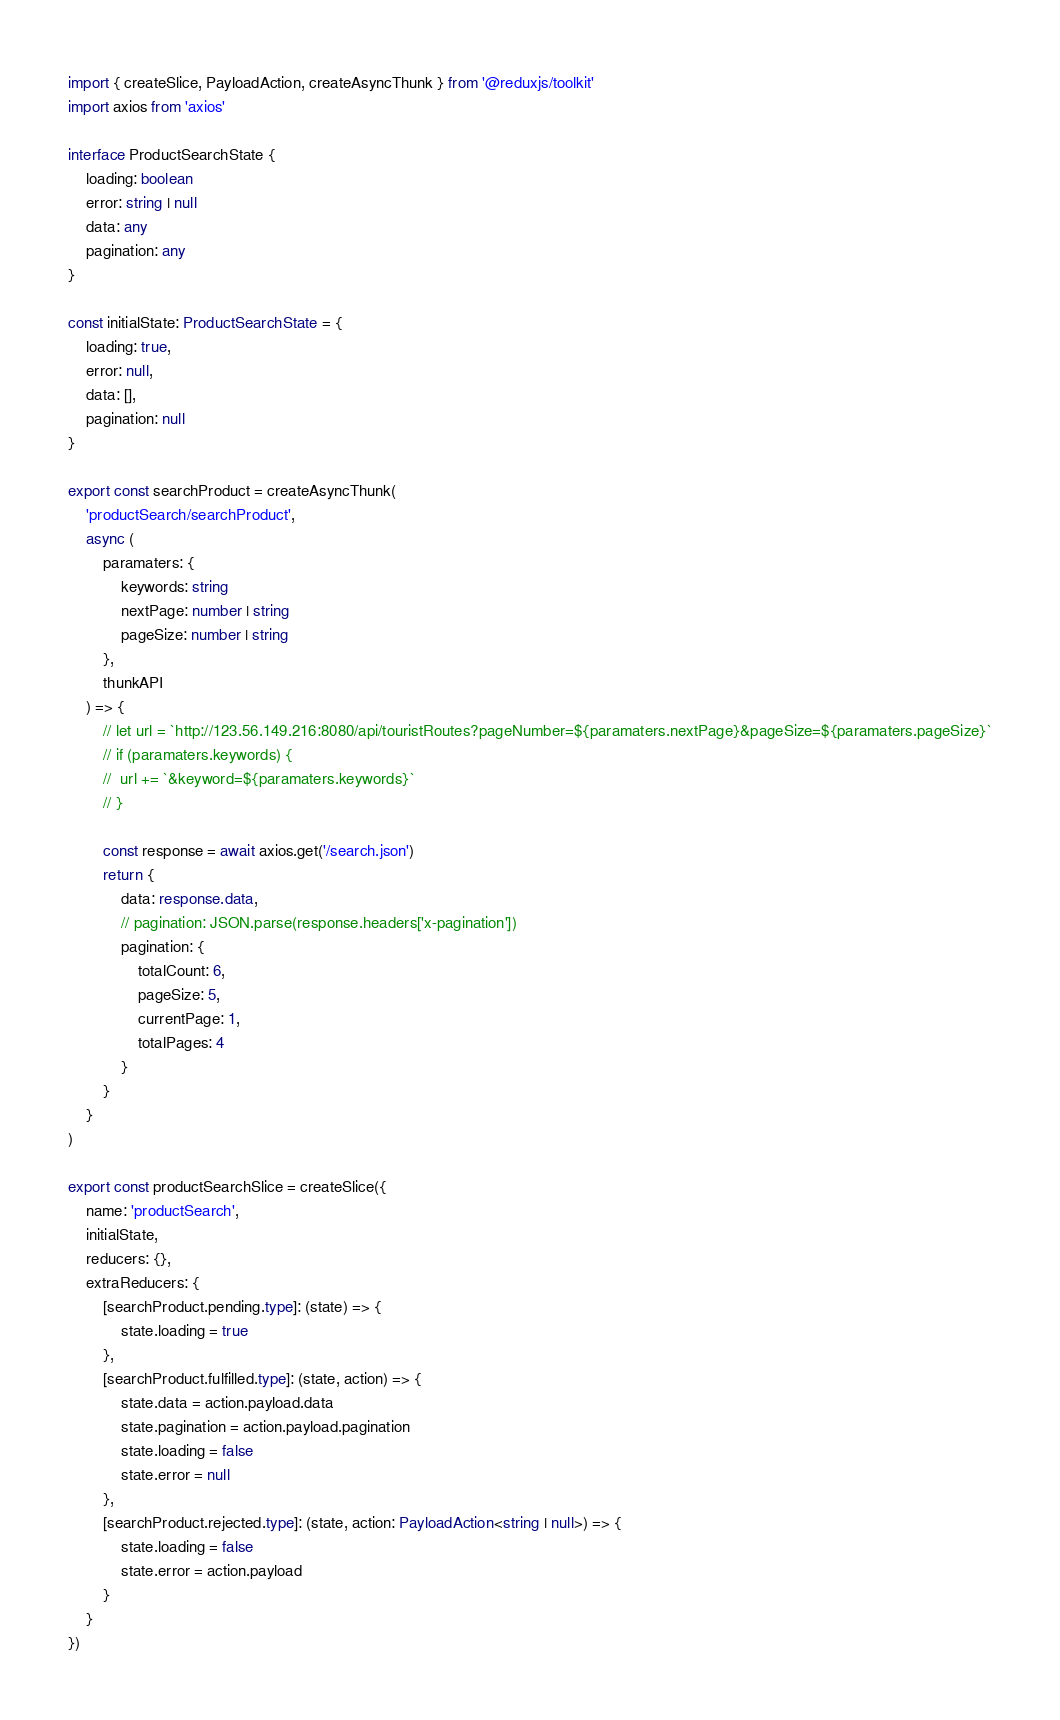<code> <loc_0><loc_0><loc_500><loc_500><_TypeScript_>import { createSlice, PayloadAction, createAsyncThunk } from '@reduxjs/toolkit'
import axios from 'axios'

interface ProductSearchState {
	loading: boolean
	error: string | null
	data: any
	pagination: any
}

const initialState: ProductSearchState = {
	loading: true,
	error: null,
	data: [],
	pagination: null
}

export const searchProduct = createAsyncThunk(
	'productSearch/searchProduct',
	async (
		paramaters: {
			keywords: string
			nextPage: number | string
			pageSize: number | string
		},
		thunkAPI
	) => {
		// let url = `http://123.56.149.216:8080/api/touristRoutes?pageNumber=${paramaters.nextPage}&pageSize=${paramaters.pageSize}`
		// if (paramaters.keywords) {
		// 	url += `&keyword=${paramaters.keywords}`
		// }

		const response = await axios.get('/search.json')
		return {
			data: response.data,
			// pagination: JSON.parse(response.headers['x-pagination'])
			pagination: {
				totalCount: 6,
				pageSize: 5,
				currentPage: 1,
				totalPages: 4
			}
		}
	}
)

export const productSearchSlice = createSlice({
	name: 'productSearch',
	initialState,
	reducers: {},
	extraReducers: {
		[searchProduct.pending.type]: (state) => {
			state.loading = true
		},
		[searchProduct.fulfilled.type]: (state, action) => {
			state.data = action.payload.data
			state.pagination = action.payload.pagination
			state.loading = false
			state.error = null
		},
		[searchProduct.rejected.type]: (state, action: PayloadAction<string | null>) => {
			state.loading = false
			state.error = action.payload
		}
	}
})
</code> 